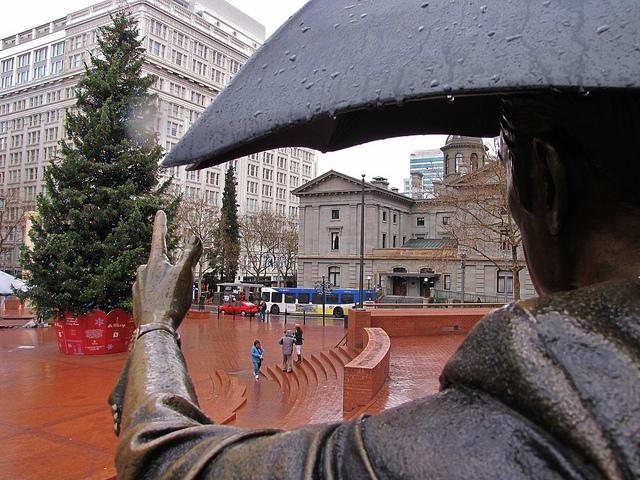When does this season take place? Please explain your reasoning. winter. The christmas tree indicates it's winter. 